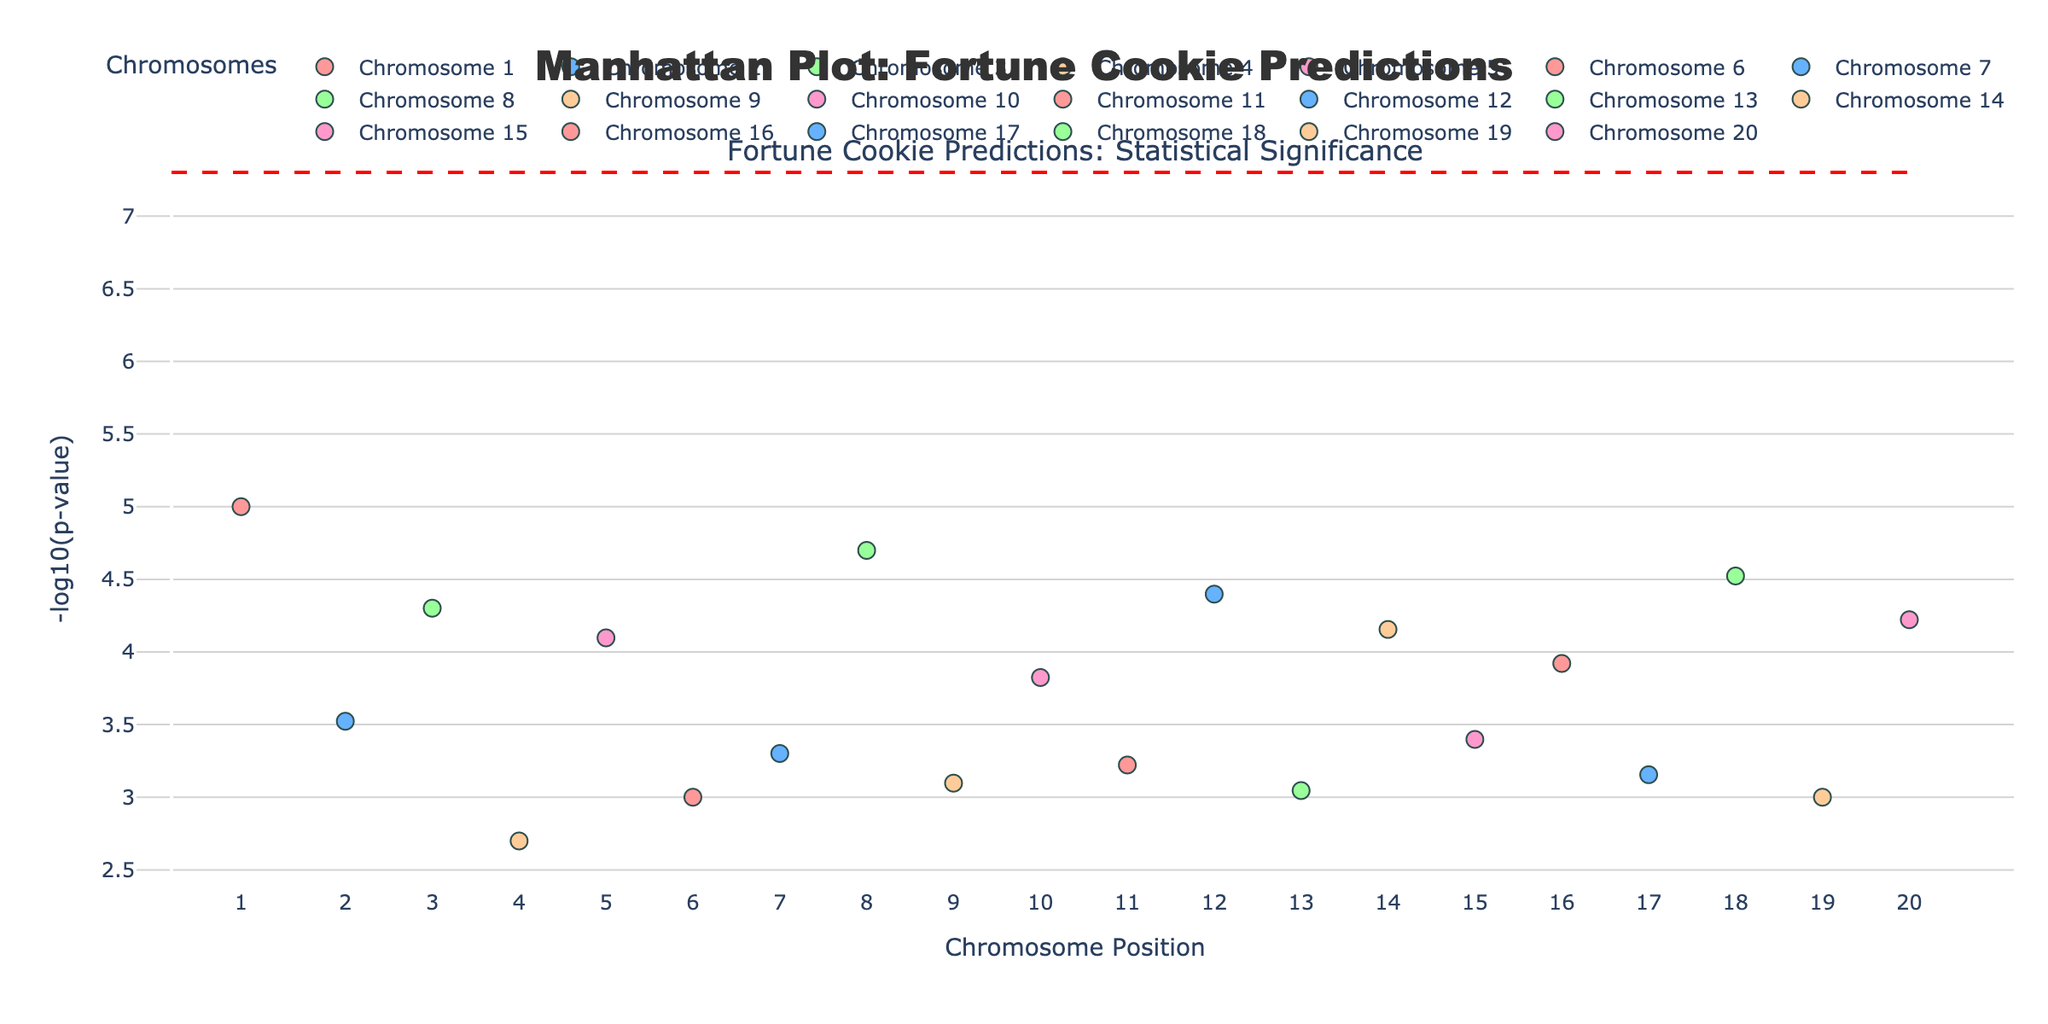What is the main title of the plot? The main title of the plot is located at the top center, and it reads "Manhattan Plot: Fortune Cookie Predictions".
Answer: Manhattan Plot: Fortune Cookie Predictions How is the y-axis labeled? The y-axis label can be found vertically along the axis, and it reads "-log10(p-value)".
Answer: -log10(p-value) What color represents chromosome 1 in the plot? The color for each chromosome is given by the custom color scale, and chromosome 1 is represented by a pink shade.
Answer: Pink Which chromosome had the prediction 'Travel opportunity'? The hover information over the data points will show the prediction associated with each chromosome and position. The 'Travel opportunity' prediction is found on chromosome 4.
Answer: Chromosome 4 How many data points are there in total in the plot? Each row in the dataset corresponds to one data point in the plot, and there is one data point per chromosome ranging from 1 to 20, making a total of 20 data points.
Answer: 20 Which prediction corresponds to the lowest p-value in the plot? Observing the y-axis, the highest value on the -log10(p) scale (indicating the lowest p-value) points to the prediction 'Career advancement' on chromosome 1.
Answer: Career advancement Which chromosome has the lowest -log10(p) value? To find the lowest -log10(p) value, look at the y-axis and identify the smallest value. This corresponds to the prediction 'Travel opportunity' on chromosome 4.
Answer: Chromosome 4 What is the significance level line set at on the plot? The significance line on the plot is represented by a dashed red line, which intersects the y-axis at -log10(5e-8).
Answer: -log10(5e-8) What is the average -log10(p) value for chromosomes 1 and 20? Find the -log10(p) values for chromosomes 1 and 20: 5.0 and 4.2218 respectively. Average these values: (5.0 + 4.2218) / 2 = 4.6109.
Answer: 4.6109 Which chromosome’s data point falls closest to the significance line? By comparing the -log10(p) values with the significance line, the datapoint closest to the significance level is from chromosome 4 with 'Travel opportunity' prediction having -log10(p) value closest to -log10(5e-8).
Answer: Chromosome 4 